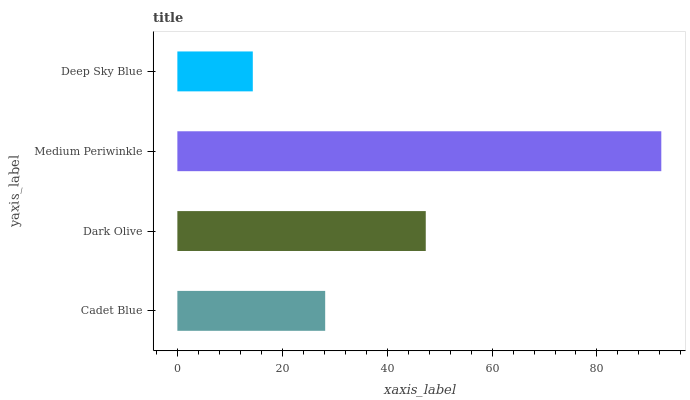Is Deep Sky Blue the minimum?
Answer yes or no. Yes. Is Medium Periwinkle the maximum?
Answer yes or no. Yes. Is Dark Olive the minimum?
Answer yes or no. No. Is Dark Olive the maximum?
Answer yes or no. No. Is Dark Olive greater than Cadet Blue?
Answer yes or no. Yes. Is Cadet Blue less than Dark Olive?
Answer yes or no. Yes. Is Cadet Blue greater than Dark Olive?
Answer yes or no. No. Is Dark Olive less than Cadet Blue?
Answer yes or no. No. Is Dark Olive the high median?
Answer yes or no. Yes. Is Cadet Blue the low median?
Answer yes or no. Yes. Is Cadet Blue the high median?
Answer yes or no. No. Is Deep Sky Blue the low median?
Answer yes or no. No. 